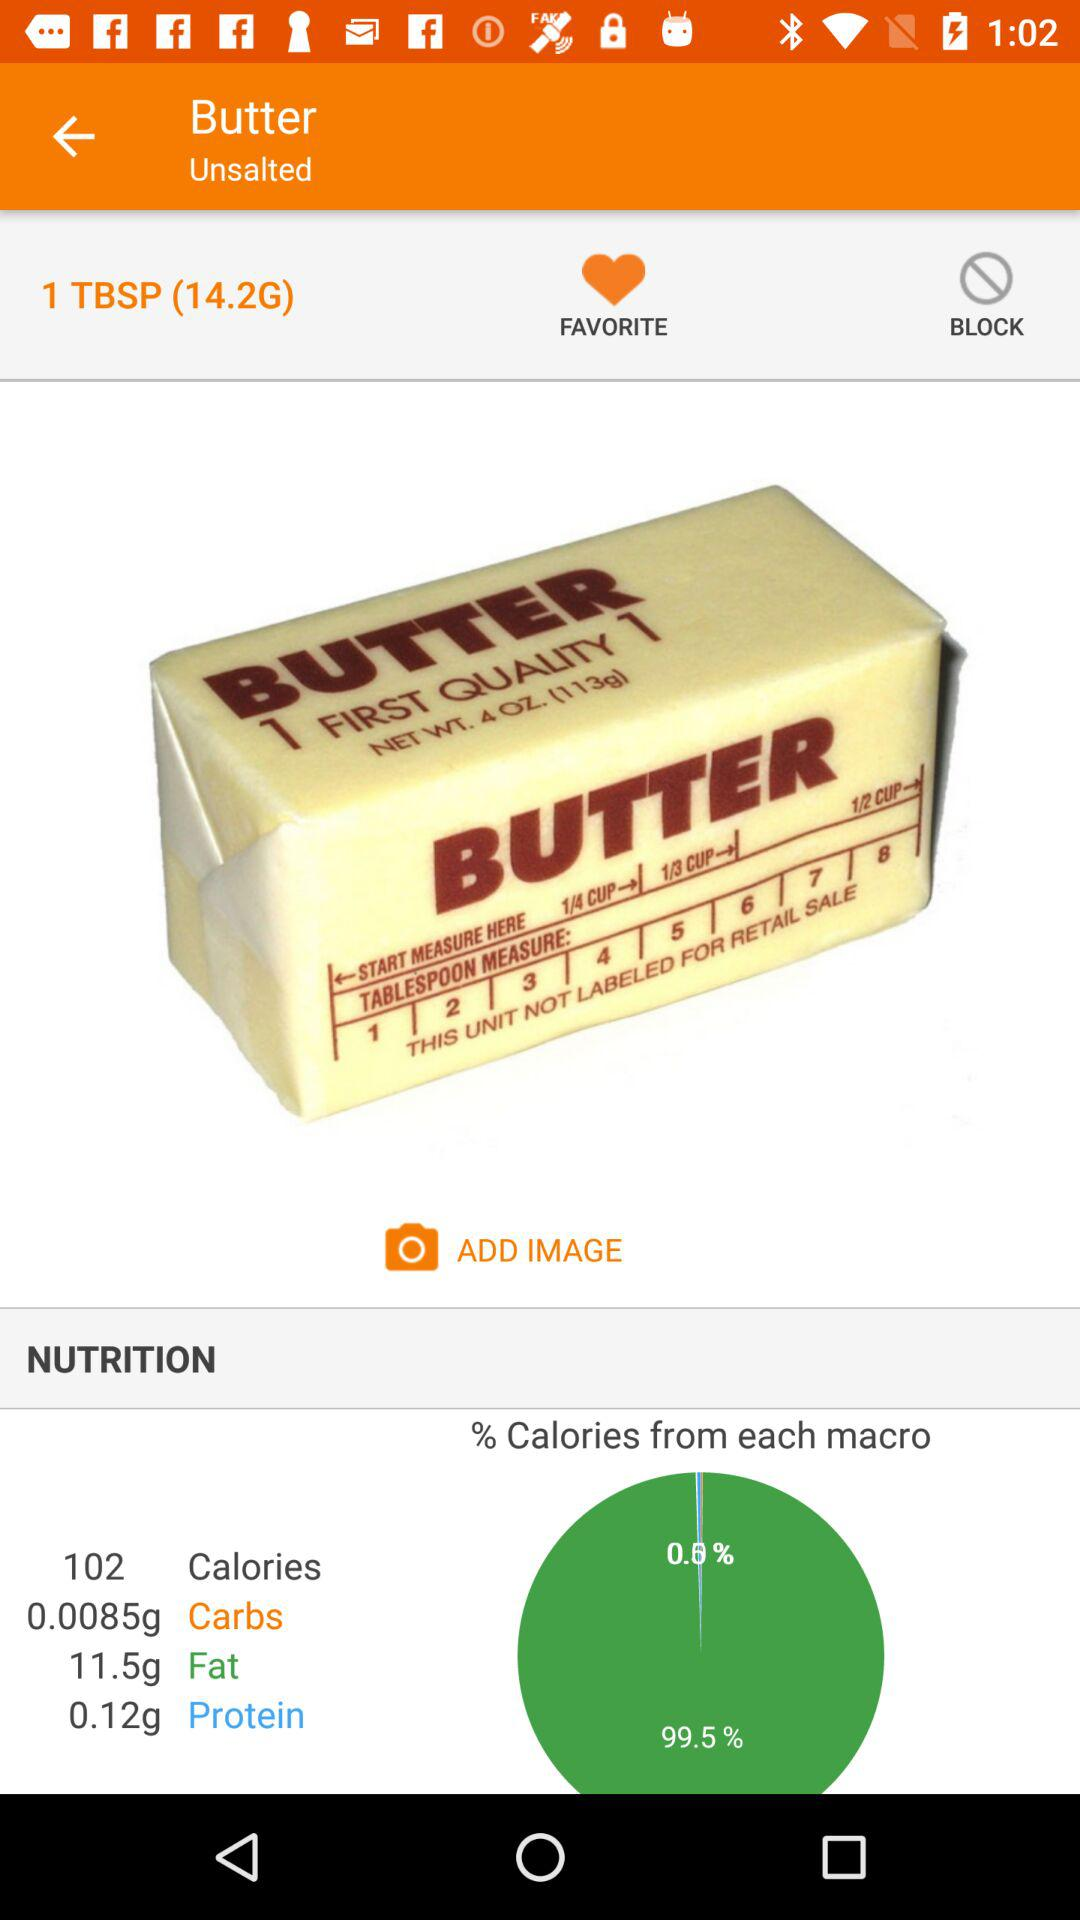What type of butter is shown? The type of butter is "Unsalted". 